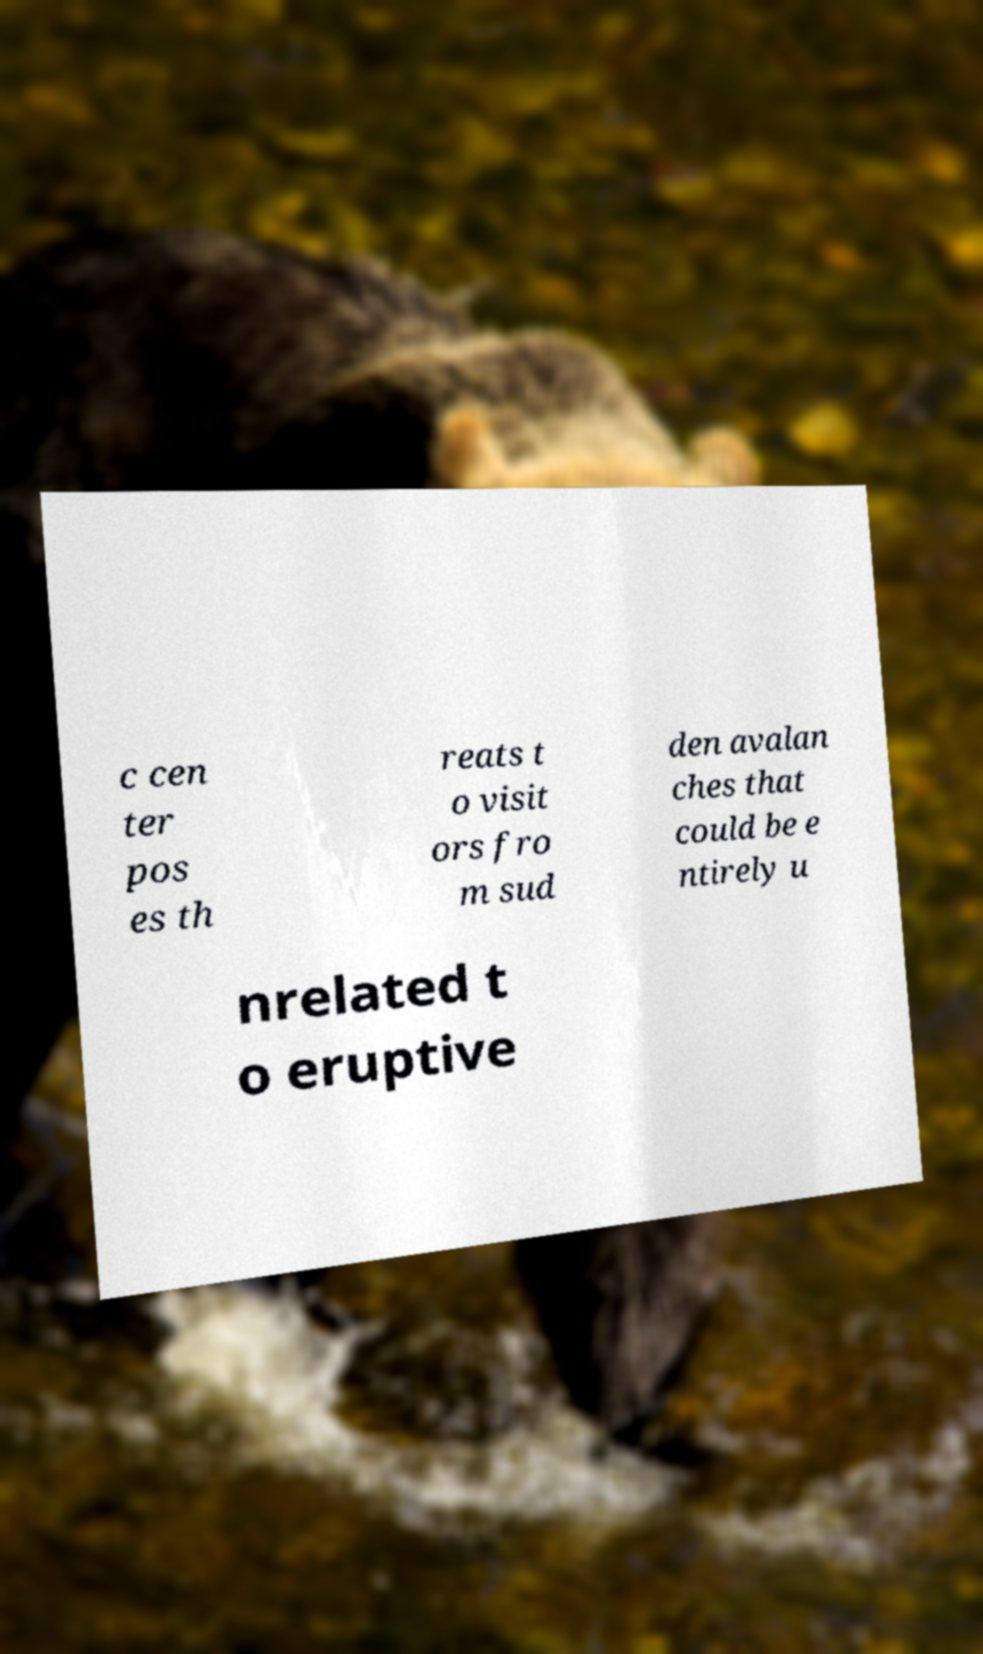Could you assist in decoding the text presented in this image and type it out clearly? c cen ter pos es th reats t o visit ors fro m sud den avalan ches that could be e ntirely u nrelated t o eruptive 